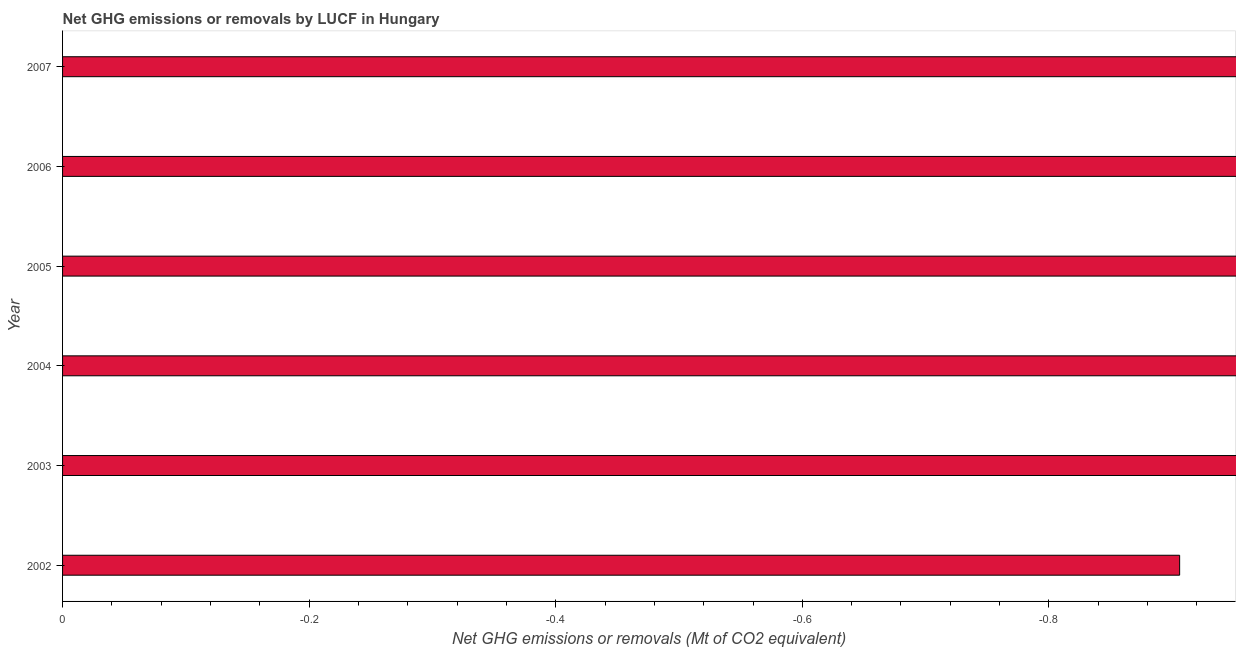Does the graph contain any zero values?
Offer a very short reply. Yes. What is the title of the graph?
Ensure brevity in your answer.  Net GHG emissions or removals by LUCF in Hungary. What is the label or title of the X-axis?
Make the answer very short. Net GHG emissions or removals (Mt of CO2 equivalent). What is the label or title of the Y-axis?
Provide a succinct answer. Year. What is the ghg net emissions or removals in 2003?
Keep it short and to the point. 0. Across all years, what is the minimum ghg net emissions or removals?
Offer a very short reply. 0. What is the sum of the ghg net emissions or removals?
Offer a very short reply. 0. What is the average ghg net emissions or removals per year?
Offer a terse response. 0. How many bars are there?
Your answer should be very brief. 0. How many years are there in the graph?
Ensure brevity in your answer.  6. What is the difference between two consecutive major ticks on the X-axis?
Keep it short and to the point. 0.2. What is the Net GHG emissions or removals (Mt of CO2 equivalent) in 2002?
Offer a very short reply. 0. What is the Net GHG emissions or removals (Mt of CO2 equivalent) of 2003?
Offer a terse response. 0. 